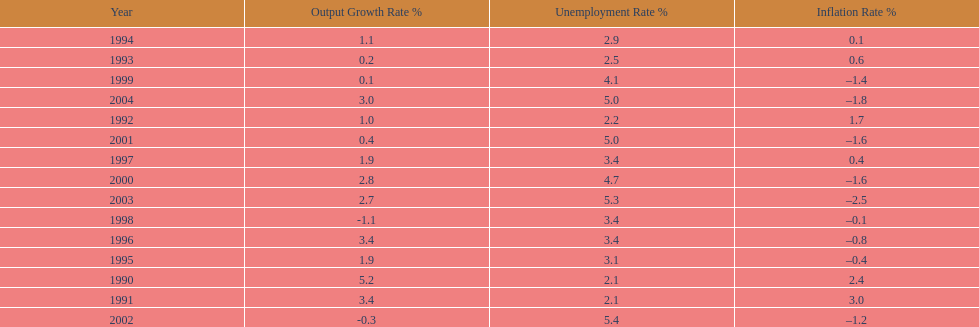When in the 1990's did the inflation rate first become negative? 1995. 